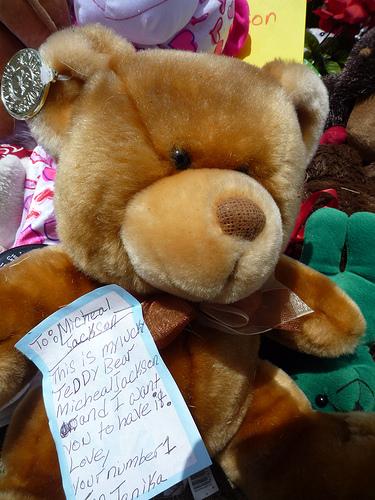Is the note typed?
Short answer required. No. Who was this teddy bear given to?
Short answer required. Michael jackson. What is this?
Write a very short answer. Teddy bear. 